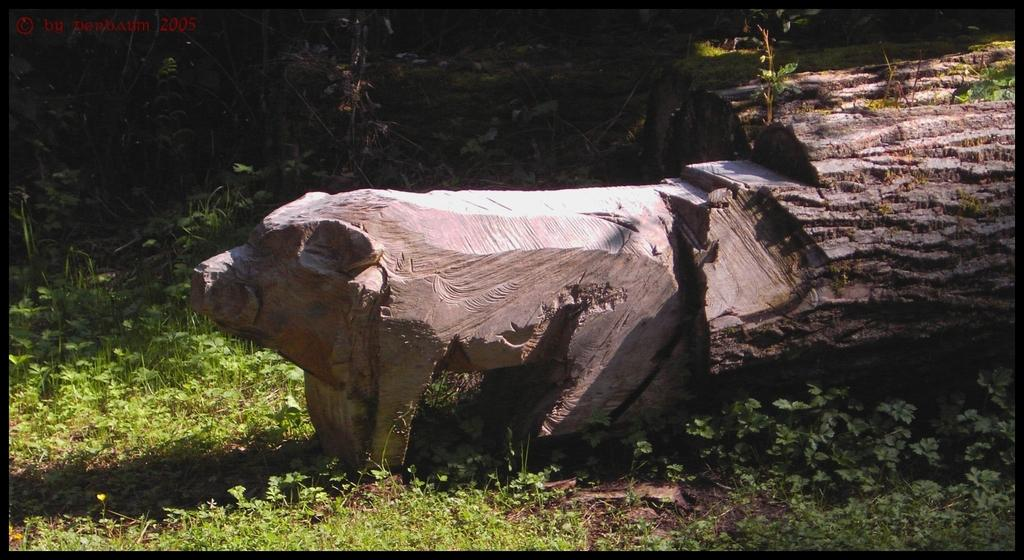What is the main subject of the image? The main subject of the image is a wooden tree trunk. What is special about the tree trunk? The tree trunk is carved. What type of vegetation is visible in the image? There is grass in the image. What can be seen in the background of the image? There are trees in the background of the image. Where is the hydrant located in the image? There is no hydrant present in the image. What type of reward is being given to the beast in the image? There is no beast or reward present in the image. 